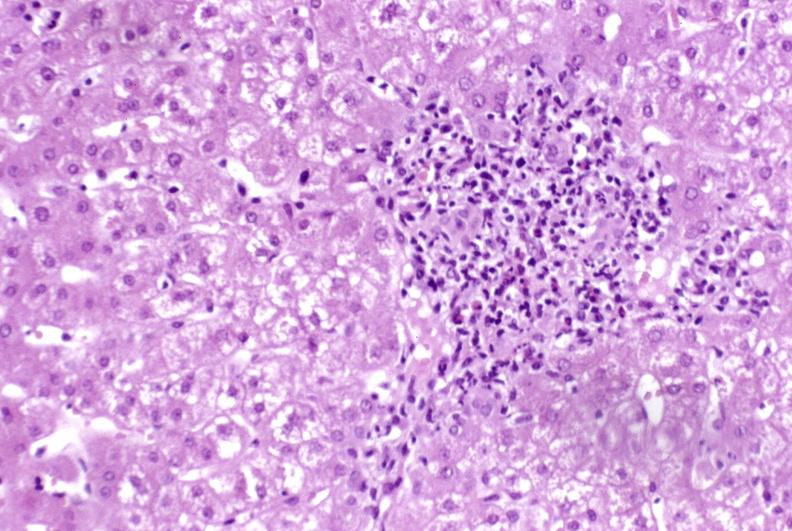does close-up tumor show moderate acute rejection?
Answer the question using a single word or phrase. No 